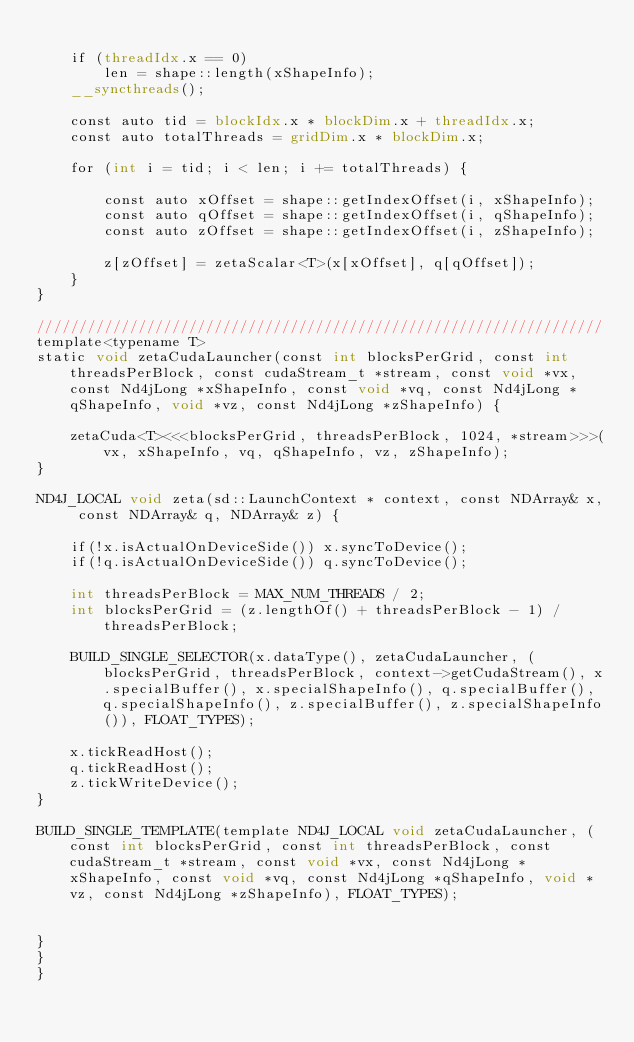Convert code to text. <code><loc_0><loc_0><loc_500><loc_500><_Cuda_>
    if (threadIdx.x == 0)
        len = shape::length(xShapeInfo);
    __syncthreads();

    const auto tid = blockIdx.x * blockDim.x + threadIdx.x;
    const auto totalThreads = gridDim.x * blockDim.x;

    for (int i = tid; i < len; i += totalThreads) {

        const auto xOffset = shape::getIndexOffset(i, xShapeInfo);
        const auto qOffset = shape::getIndexOffset(i, qShapeInfo);
        const auto zOffset = shape::getIndexOffset(i, zShapeInfo);

        z[zOffset] = zetaScalar<T>(x[xOffset], q[qOffset]);
    }
}

///////////////////////////////////////////////////////////////////
template<typename T>
static void zetaCudaLauncher(const int blocksPerGrid, const int threadsPerBlock, const cudaStream_t *stream, const void *vx, const Nd4jLong *xShapeInfo, const void *vq, const Nd4jLong *qShapeInfo, void *vz, const Nd4jLong *zShapeInfo) {

    zetaCuda<T><<<blocksPerGrid, threadsPerBlock, 1024, *stream>>>(vx, xShapeInfo, vq, qShapeInfo, vz, zShapeInfo);
}

ND4J_LOCAL void zeta(sd::LaunchContext * context, const NDArray& x, const NDArray& q, NDArray& z) {

    if(!x.isActualOnDeviceSide()) x.syncToDevice();
    if(!q.isActualOnDeviceSide()) q.syncToDevice();

    int threadsPerBlock = MAX_NUM_THREADS / 2;
    int blocksPerGrid = (z.lengthOf() + threadsPerBlock - 1) / threadsPerBlock;

    BUILD_SINGLE_SELECTOR(x.dataType(), zetaCudaLauncher, (blocksPerGrid, threadsPerBlock, context->getCudaStream(), x.specialBuffer(), x.specialShapeInfo(), q.specialBuffer(), q.specialShapeInfo(), z.specialBuffer(), z.specialShapeInfo()), FLOAT_TYPES);

    x.tickReadHost();
    q.tickReadHost();
    z.tickWriteDevice();
}

BUILD_SINGLE_TEMPLATE(template ND4J_LOCAL void zetaCudaLauncher, (const int blocksPerGrid, const int threadsPerBlock, const cudaStream_t *stream, const void *vx, const Nd4jLong *xShapeInfo, const void *vq, const Nd4jLong *qShapeInfo, void *vz, const Nd4jLong *zShapeInfo), FLOAT_TYPES);


}
}
}

</code> 